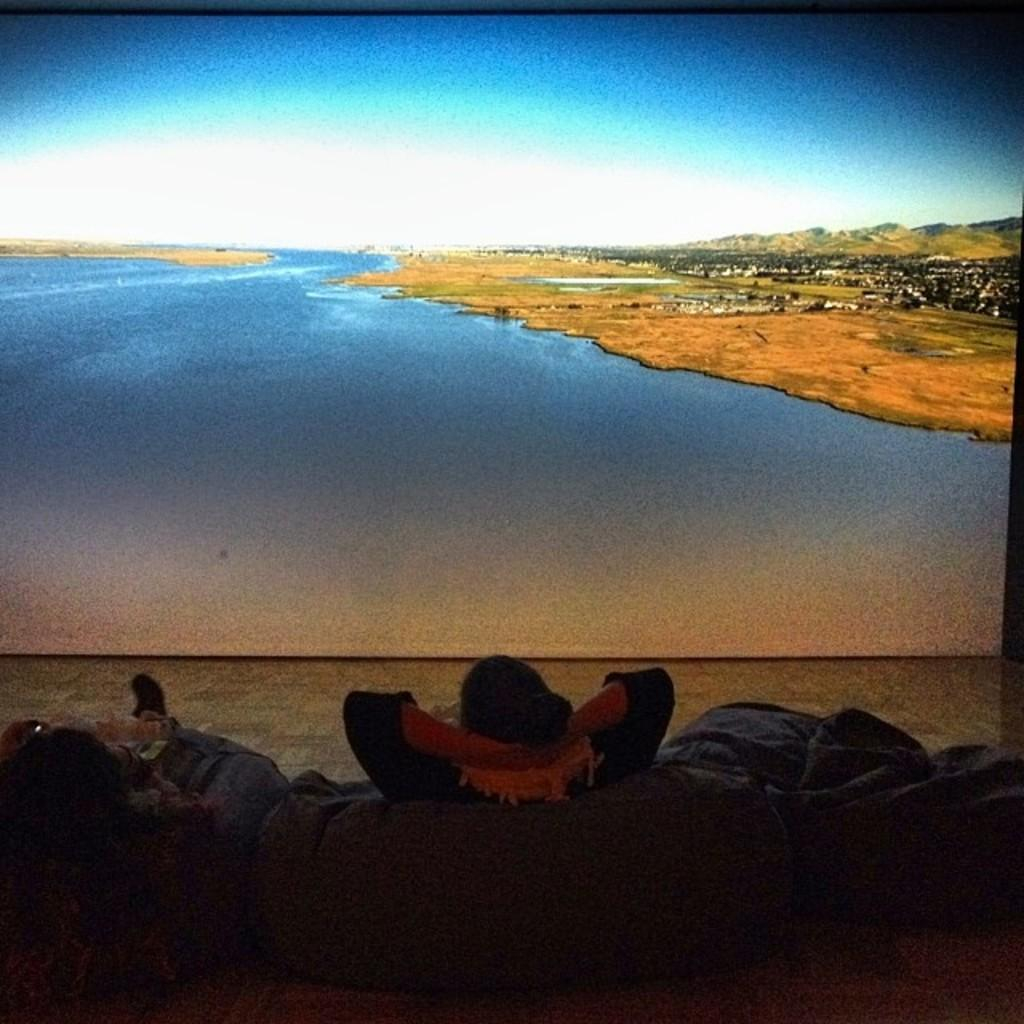What are the two people sitting on in the image? The two people are sitting on bean bags. What is in front of the people? There is a screen in front of the people. What can be seen on the screen? The screen displays mountains, a river, and the sky. Where is the market located in the image? There is no market present in the image. What type of control can be seen on the bean bags? There are no controls visible on the bean bags in the image. 